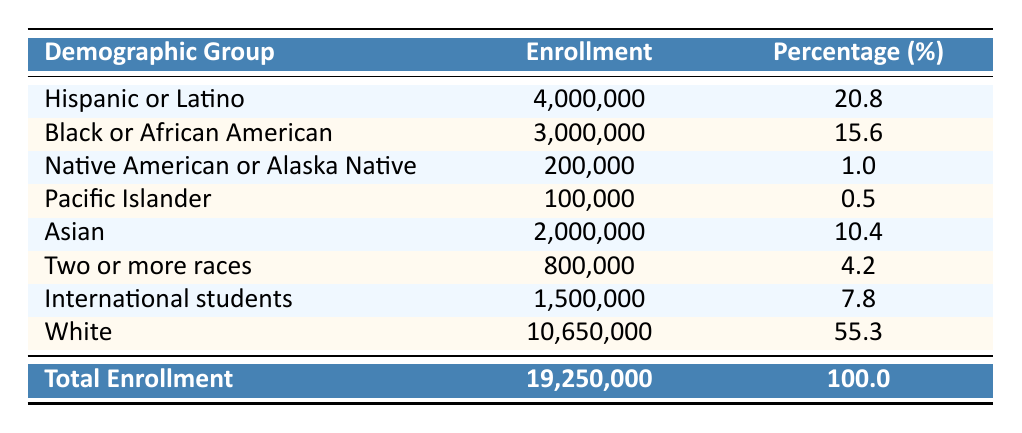What is the total enrollment for Hispanic or Latino students in 2023? From the table, the enrollment number for Hispanic or Latino students is given directly as 4,000,000.
Answer: 4,000,000 What percentage of the total enrollment does the Black or African American group represent? The table indicates that the Black or African American group represents 15.6% of the total enrollment.
Answer: 15.6 How many more students are enrolled in Hispanic or Latino groups than in Pacific Islander groups? The Hispanic or Latino group has 4,000,000 enrolled, while the Pacific Islander group has 100,000. The difference is calculated as 4,000,000 - 100,000 = 3,900,000.
Answer: 3,900,000 What is the enrollment percentage of underrepresented groups combined (considering only groups that are not White)? To find this, we sum the enrollment of all groups except for White: 4,000,000 (Hispanic) + 3,000,000 (Black) + 200,000 (Native American) + 100,000 (Pacific Islander) + 2,000,000 (Asian) + 800,000 (Two or more races) + 1,500,000 (International) = 11,600,000. Then, we calculate the percentage of this total by taking (11,600,000 / 19,250,000) * 100 which equals approximately 60.3%.
Answer: 60.3 Is the enrollment of Native American or Alaska Native students greater than the enrollment of Pacific Islander students? The table shows that the enrollment for Native American or Alaska Native students is 200,000, while for Pacific Islander students, it's 100,000. Since 200,000 is greater than 100,000, the statement is true.
Answer: Yes What is the combined enrollment of Asian and International students? According to the table, Asian students have an enrollment of 2,000,000 and International students have 1,500,000. Adding these together gives 2,000,000 + 1,500,000 = 3,500,000.
Answer: 3,500,000 Is the total enrollment for underrepresented groups less than half of the total enrollment? The total enrollment of underrepresented groups is 11,600,000. Half of the total enrollment (19,250,000) is 9,625,000. Since 11,600,000 is more than 9,625,000, the statement is false.
Answer: No What percentage of the total enrollment do White students constitute? The percentage for White students is clearly stated in the table as 55.3%.
Answer: 55.3 